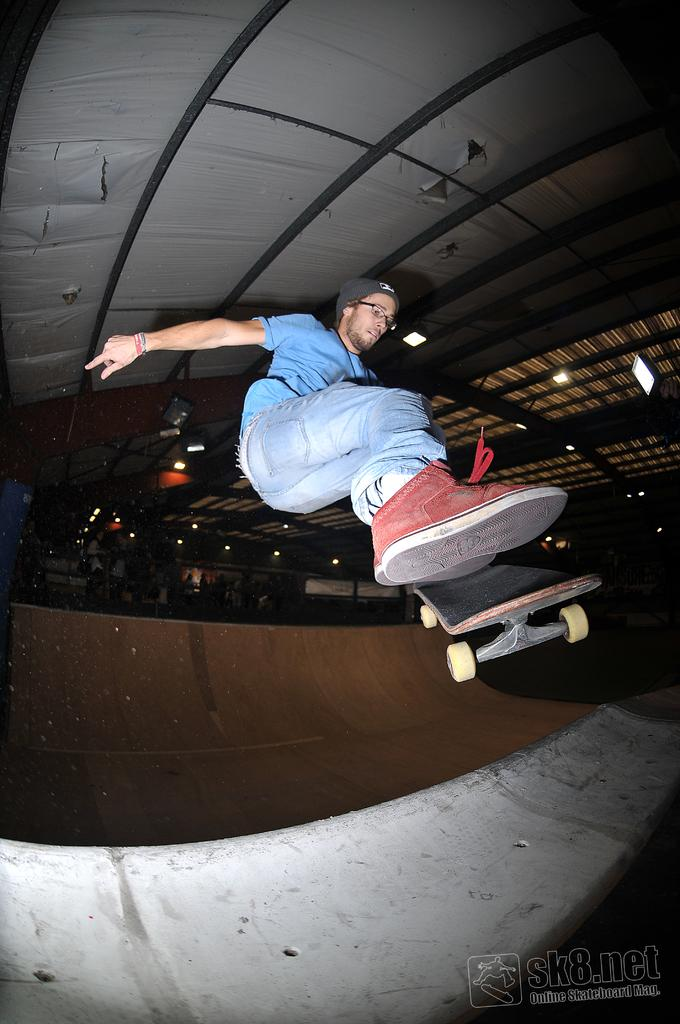What is the person in the image doing? The person is skating with a skateboard in the image. Where is the skating taking place? The skating is taking place in a skating park. What can be seen above the person in the image? There is a ceiling visible in the image. What is present in the bottom right corner of the image? There is text in the bottom right corner of the image. What type of instrument is the person playing while skating in the image? There is no instrument present in the image; the person is skating with a skateboard. How many beds can be seen in the image? There are no beds present in the image. 